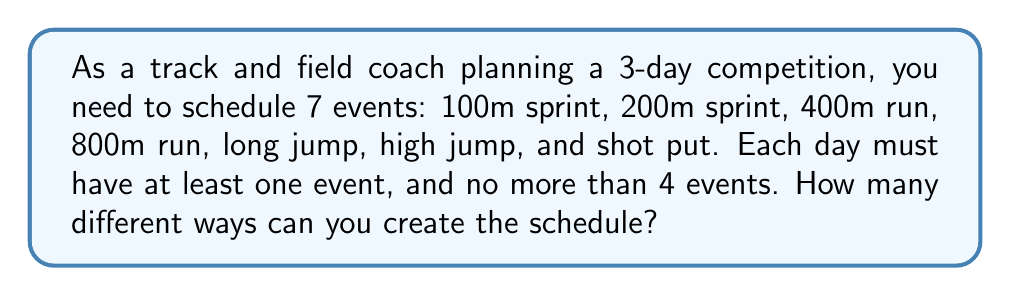Can you solve this math problem? Let's approach this step-by-step:

1) First, we need to distribute 7 events over 3 days. This is a partition problem.

2) The possible partitions of 7 into 3 parts, where each part is at least 1 and at most 4, are:
   (1,1,5), (1,2,4), (1,3,3), (2,2,3)

3) Now, for each partition, we need to calculate the number of ways to arrange the events:

   a) For (1,1,5): This is not valid as one day has 5 events, which exceeds our maximum of 4.

   b) For (1,2,4):
      - Choose 1 event for day 1: $\binom{7}{1} = 7$ ways
      - Choose 2 events for day 2 from remaining 6: $\binom{6}{2} = 15$ ways
      - The remaining 4 events go to day 3: 1 way
      Total for this partition: $7 \times 15 \times 1 = 105$ ways

   c) For (1,3,3):
      - Choose 1 event for day 1: $\binom{7}{1} = 7$ ways
      - Choose 3 events for day 2 from remaining 6: $\binom{6}{3} = 20$ ways
      - The remaining 3 events go to day 3: 1 way
      Total for this partition: $7 \times 20 \times 1 = 140$ ways

   d) For (2,2,3):
      - Choose 2 events for day 1: $\binom{7}{2} = 21$ ways
      - Choose 2 events for day 2 from remaining 5: $\binom{5}{2} = 10$ ways
      - The remaining 3 events go to day 3: 1 way
      Total for this partition: $21 \times 10 \times 1 = 210$ ways

4) The total number of possible schedules is the sum of all valid partitions:
   $105 + 140 + 210 = 455$
Answer: 455 